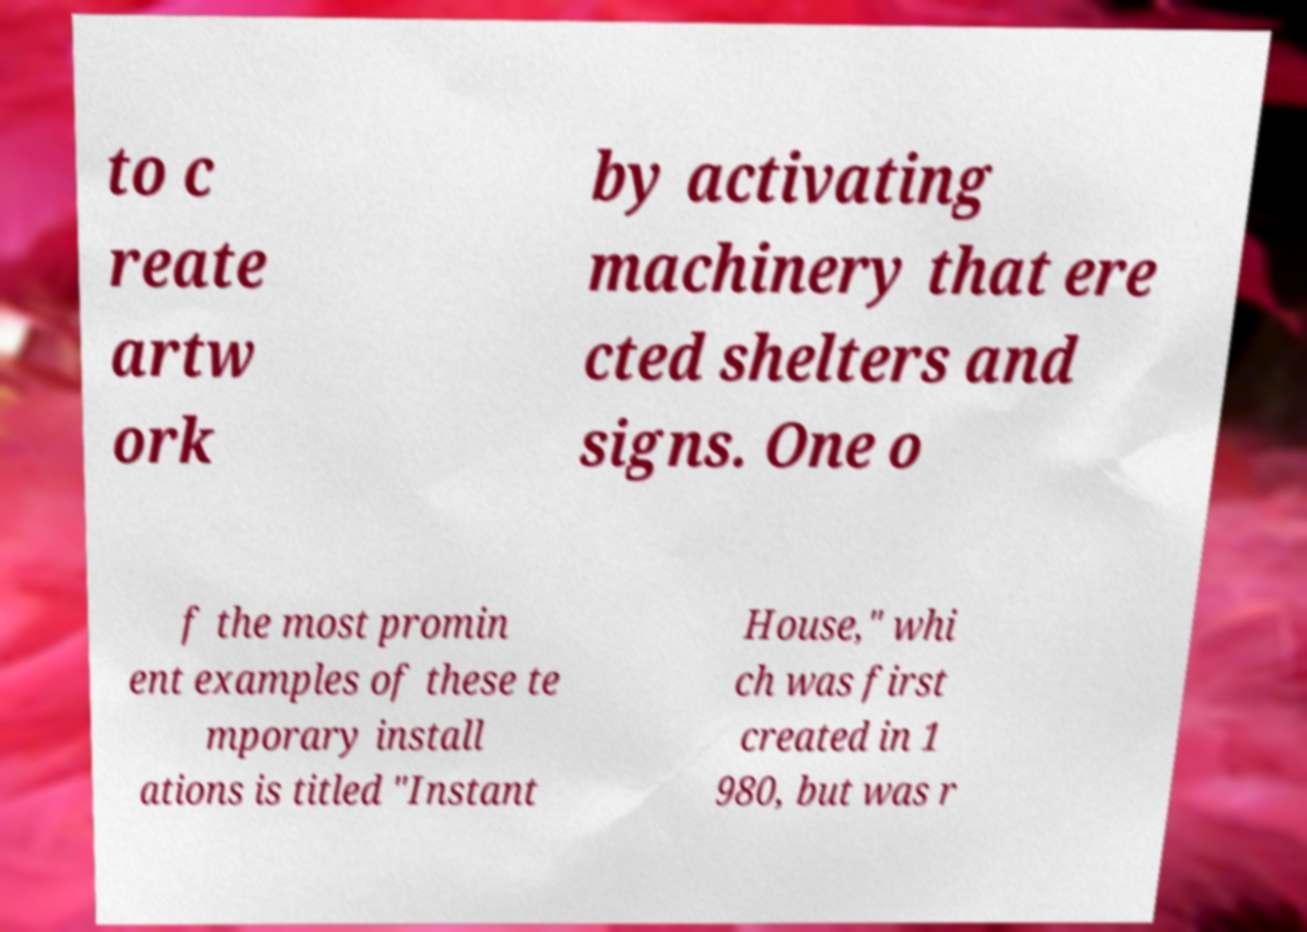I need the written content from this picture converted into text. Can you do that? to c reate artw ork by activating machinery that ere cted shelters and signs. One o f the most promin ent examples of these te mporary install ations is titled "Instant House," whi ch was first created in 1 980, but was r 